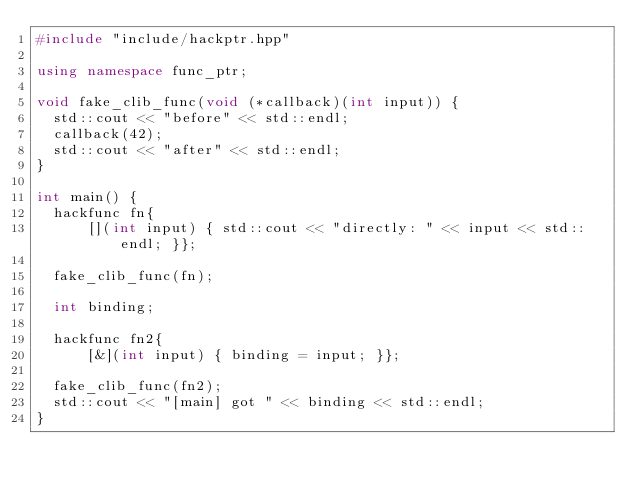<code> <loc_0><loc_0><loc_500><loc_500><_C++_>#include "include/hackptr.hpp"

using namespace func_ptr;

void fake_clib_func(void (*callback)(int input)) {
  std::cout << "before" << std::endl;
  callback(42);
  std::cout << "after" << std::endl;
}

int main() {
  hackfunc fn{
      [](int input) { std::cout << "directly: " << input << std::endl; }};
  
  fake_clib_func(fn);

  int binding;

  hackfunc fn2{
      [&](int input) { binding = input; }};
  
  fake_clib_func(fn2);
  std::cout << "[main] got " << binding << std::endl;
}</code> 